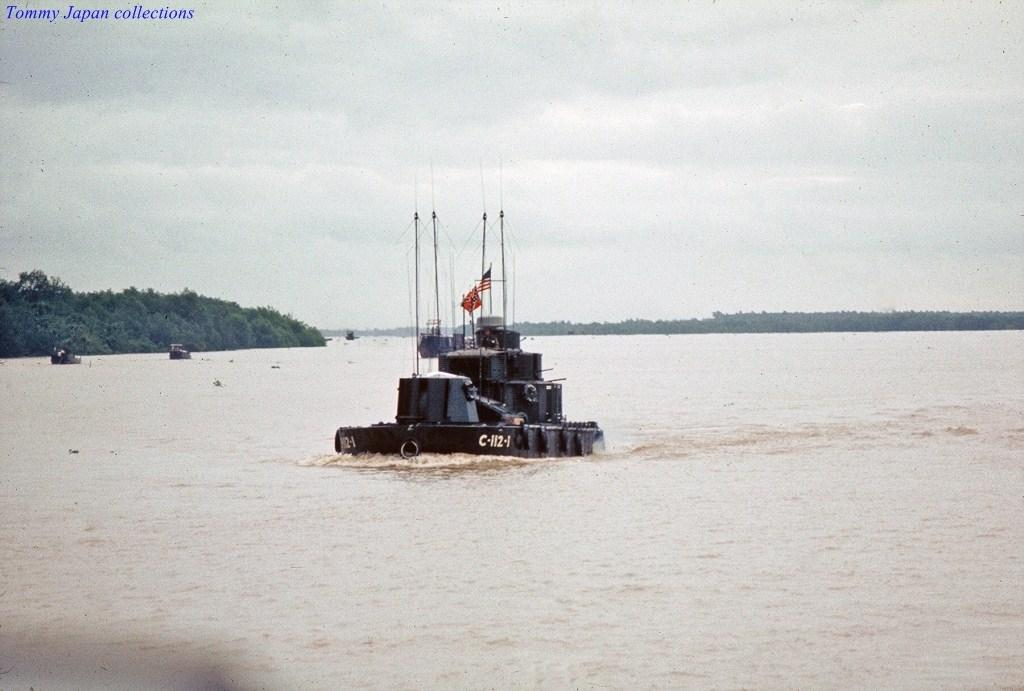<image>
Render a clear and concise summary of the photo. A boat with a number C-112-1 is moving through muddy waters. 